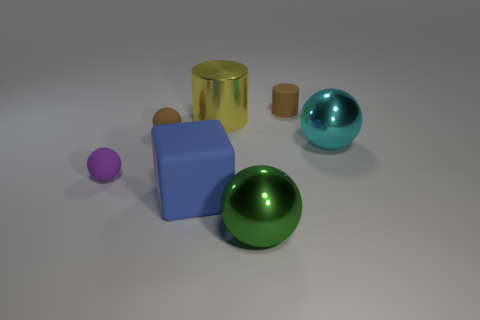How many large cubes are right of the small cylinder?
Your response must be concise. 0. The yellow cylinder has what size?
Provide a succinct answer. Large. Is the material of the brown thing to the right of the green metal ball the same as the ball that is behind the cyan ball?
Ensure brevity in your answer.  Yes. Is there a ball that has the same color as the tiny rubber cylinder?
Your answer should be very brief. Yes. There is another matte thing that is the same size as the green thing; what color is it?
Offer a very short reply. Blue. There is a rubber sphere that is behind the small purple matte thing; does it have the same color as the tiny cylinder?
Your response must be concise. Yes. Are there any large cyan spheres made of the same material as the yellow object?
Provide a succinct answer. Yes. Are there fewer big yellow metal cylinders that are on the right side of the cyan object than small rubber things?
Provide a succinct answer. Yes. There is a brown rubber object right of the yellow shiny cylinder; does it have the same size as the small purple object?
Keep it short and to the point. Yes. How many other big things are the same shape as the large yellow thing?
Provide a short and direct response. 0. 